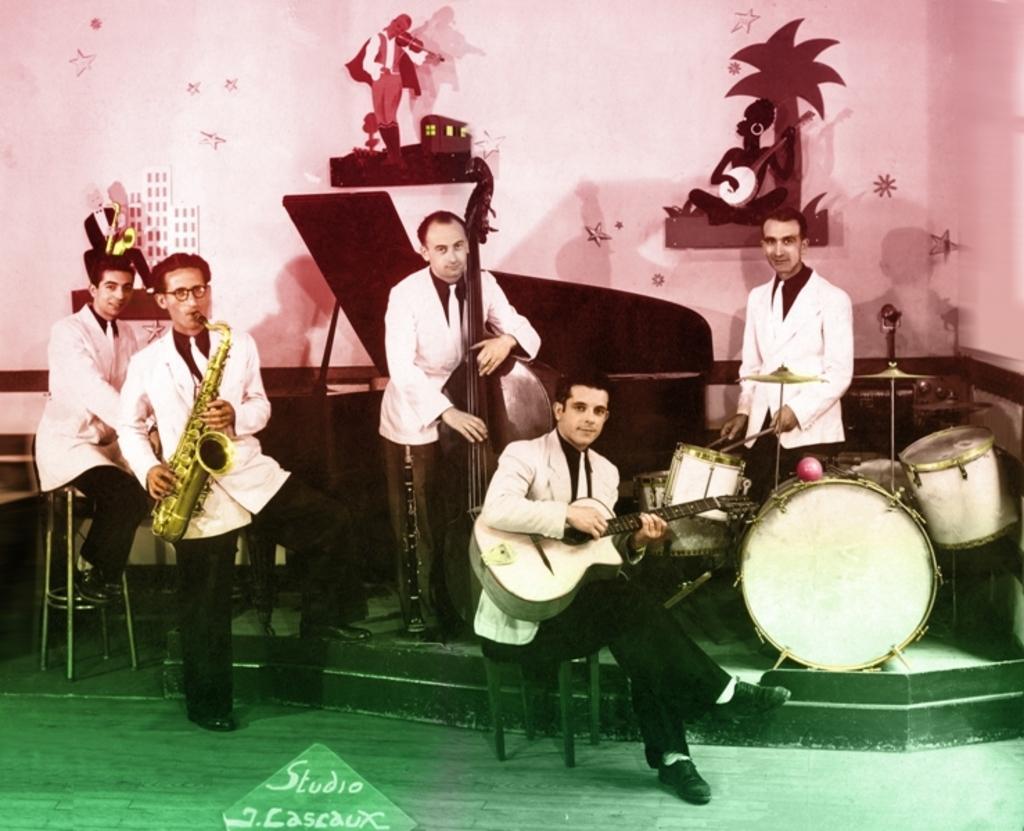Please provide a concise description of this image. There are 5 men with musical instruments in their hand and giving pose. Behind them there are wall stickers on the wall. 